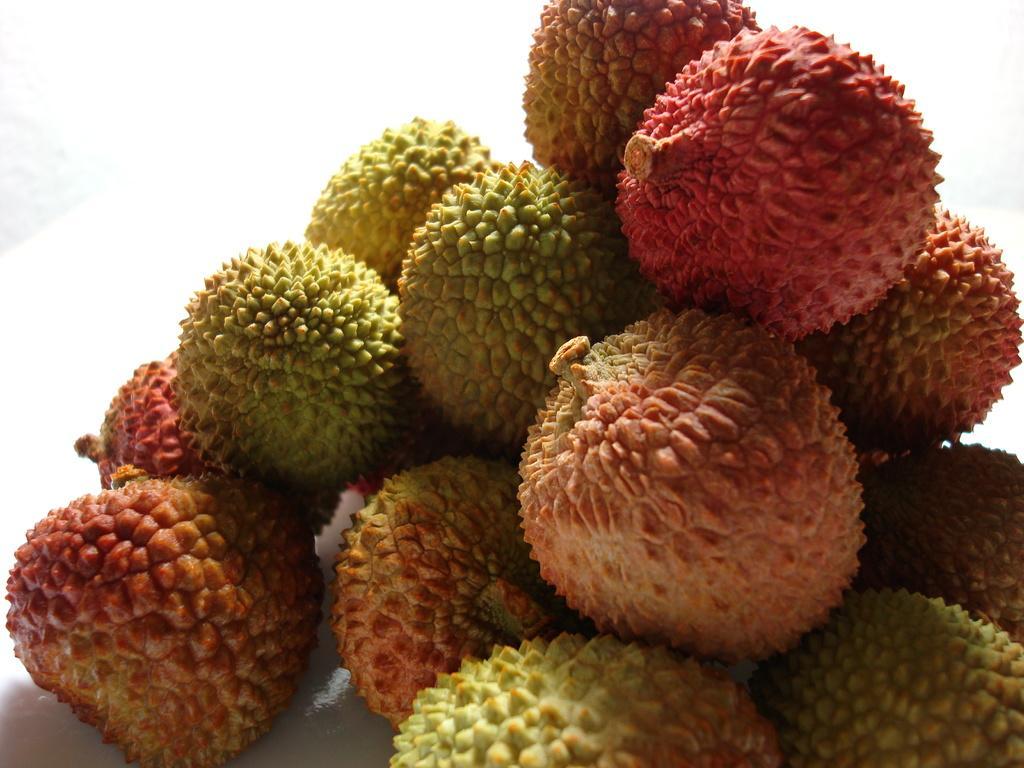Describe this image in one or two sentences. In the picture I can see few lychee fruits which is in different colors. 